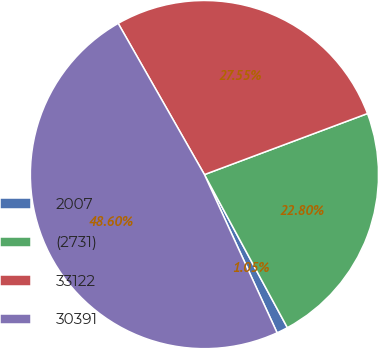Convert chart to OTSL. <chart><loc_0><loc_0><loc_500><loc_500><pie_chart><fcel>2007<fcel>(2731)<fcel>33122<fcel>30391<nl><fcel>1.05%<fcel>22.8%<fcel>27.55%<fcel>48.6%<nl></chart> 